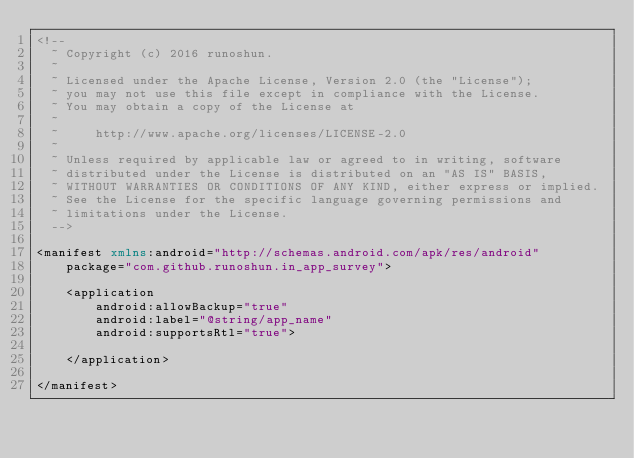Convert code to text. <code><loc_0><loc_0><loc_500><loc_500><_XML_><!--
  ~ Copyright (c) 2016 runoshun.
  ~
  ~ Licensed under the Apache License, Version 2.0 (the "License");
  ~ you may not use this file except in compliance with the License.
  ~ You may obtain a copy of the License at
  ~
  ~     http://www.apache.org/licenses/LICENSE-2.0
  ~
  ~ Unless required by applicable law or agreed to in writing, software
  ~ distributed under the License is distributed on an "AS IS" BASIS,
  ~ WITHOUT WARRANTIES OR CONDITIONS OF ANY KIND, either express or implied.
  ~ See the License for the specific language governing permissions and
  ~ limitations under the License.
  -->

<manifest xmlns:android="http://schemas.android.com/apk/res/android"
    package="com.github.runoshun.in_app_survey">

    <application
        android:allowBackup="true"
        android:label="@string/app_name"
        android:supportsRtl="true">

    </application>

</manifest>
</code> 